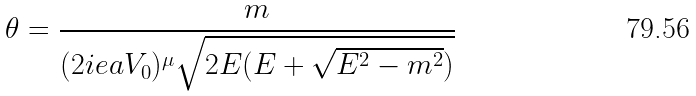Convert formula to latex. <formula><loc_0><loc_0><loc_500><loc_500>\theta = \frac { m } { ( 2 i e a V _ { 0 } ) ^ { \mu } \sqrt { 2 E ( E + \sqrt { E ^ { 2 } - m ^ { 2 } } ) } }</formula> 